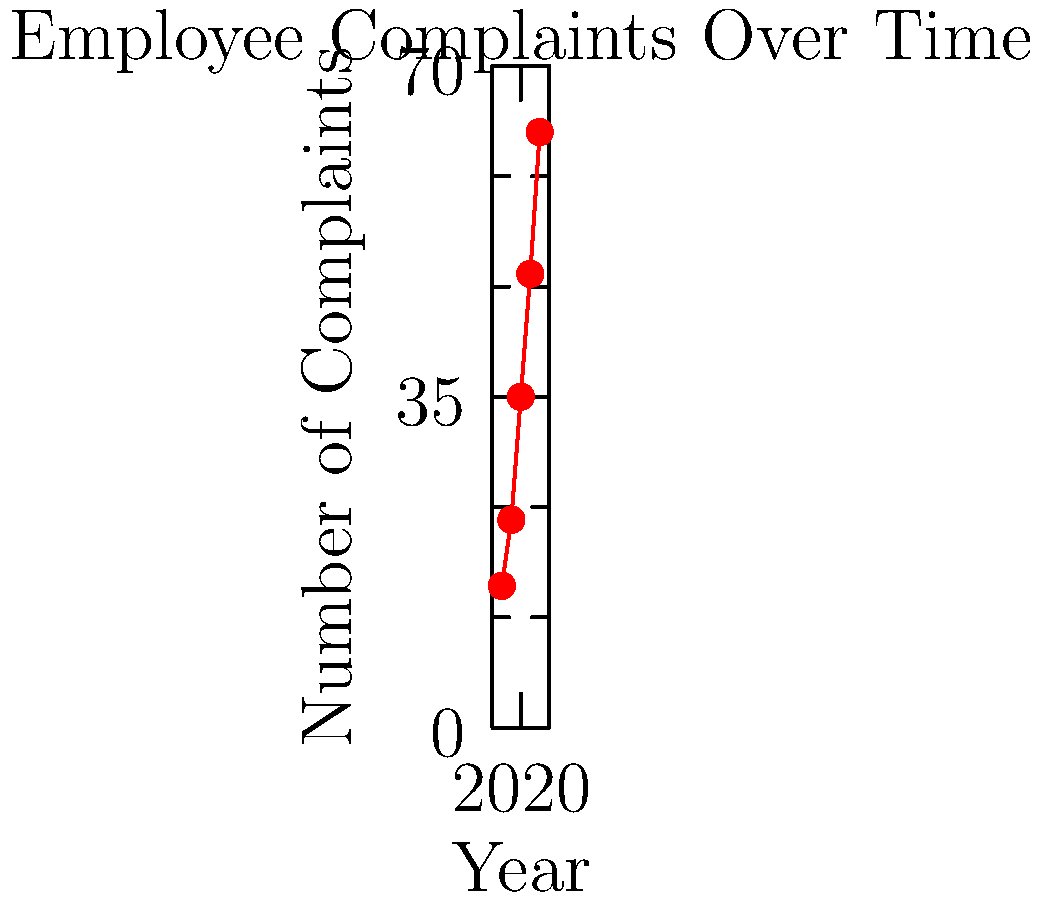Based on the bar graph showing employee complaints over time, what is the average yearly increase in the number of complaints between 2018 and 2022? To calculate the average yearly increase in complaints:

1. Calculate the total increase from 2018 to 2022:
   2022 complaints: 63
   2018 complaints: 15
   Total increase: 63 - 15 = 48

2. Determine the number of years between 2018 and 2022:
   2022 - 2018 = 4 years

3. Calculate the average yearly increase:
   Average increase = Total increase ÷ Number of years
   $\frac{48}{4} = 12$

Therefore, the average yearly increase in complaints between 2018 and 2022 is 12.

This trend suggests a consistent rise in employee dissatisfaction or increasing awareness of unethical practices within the company over time.
Answer: 12 complaints per year 